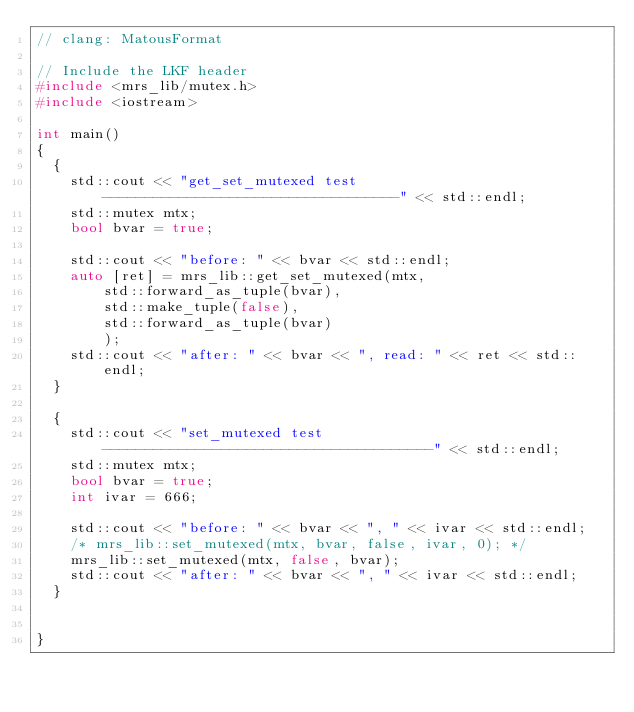Convert code to text. <code><loc_0><loc_0><loc_500><loc_500><_C++_>// clang: MatousFormat

// Include the LKF header
#include <mrs_lib/mutex.h>
#include <iostream>

int main()
{
  {
    std::cout << "get_set_mutexed test -----------------------------------" << std::endl;
    std::mutex mtx;
    bool bvar = true;

    std::cout << "before: " << bvar << std::endl;
    auto [ret] = mrs_lib::get_set_mutexed(mtx,
        std::forward_as_tuple(bvar),
        std::make_tuple(false),
        std::forward_as_tuple(bvar)
        );
    std::cout << "after: " << bvar << ", read: " << ret << std::endl;
  }

  {
    std::cout << "set_mutexed test ---------------------------------------" << std::endl;
    std::mutex mtx;
    bool bvar = true;
    int ivar = 666;

    std::cout << "before: " << bvar << ", " << ivar << std::endl;
    /* mrs_lib::set_mutexed(mtx, bvar, false, ivar, 0); */
    mrs_lib::set_mutexed(mtx, false, bvar);
    std::cout << "after: " << bvar << ", " << ivar << std::endl;
  }


}



</code> 